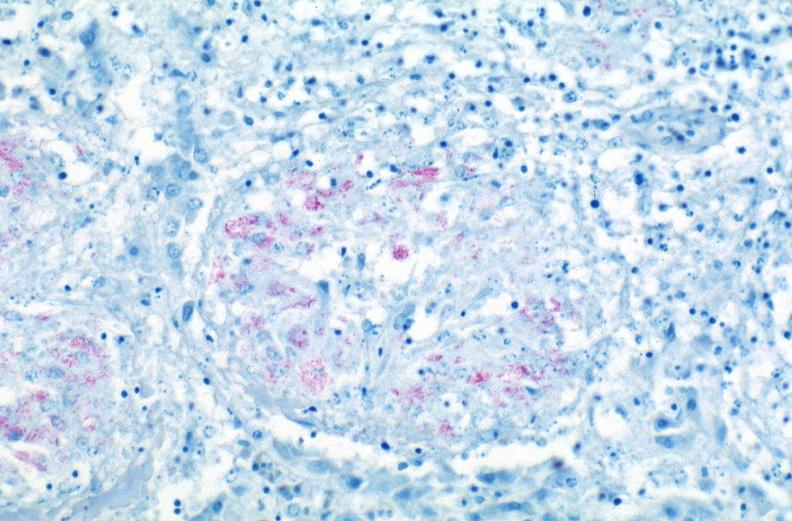s respiratory present?
Answer the question using a single word or phrase. Yes 